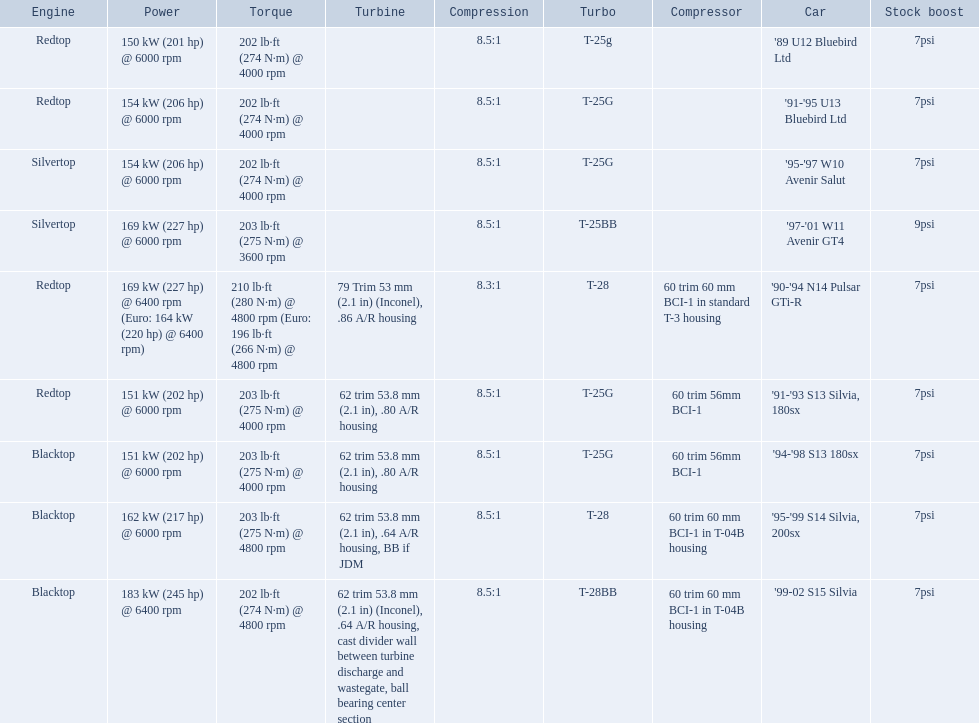What are all the cars? '89 U12 Bluebird Ltd, '91-'95 U13 Bluebird Ltd, '95-'97 W10 Avenir Salut, '97-'01 W11 Avenir GT4, '90-'94 N14 Pulsar GTi-R, '91-'93 S13 Silvia, 180sx, '94-'98 S13 180sx, '95-'99 S14 Silvia, 200sx, '99-02 S15 Silvia. What are their stock boosts? 7psi, 7psi, 7psi, 9psi, 7psi, 7psi, 7psi, 7psi, 7psi. And which car has the highest stock boost? '97-'01 W11 Avenir GT4. 